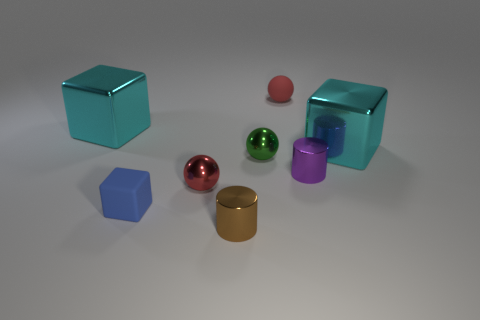Are there any rubber cubes that have the same color as the rubber sphere? After examining the image, no rubber cubes match the color of the rubber sphere exactly. The cubes and the sphere present distinct hues, indicating there are no identical colors among them. 